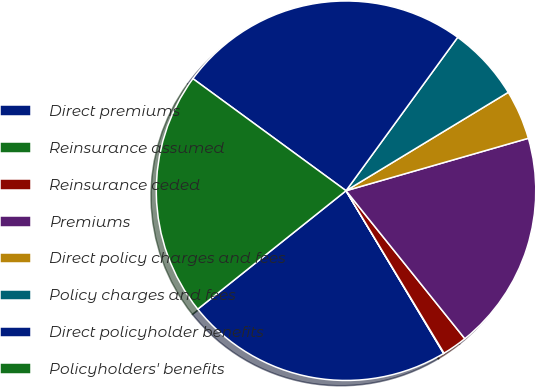Convert chart. <chart><loc_0><loc_0><loc_500><loc_500><pie_chart><fcel>Direct premiums<fcel>Reinsurance assumed<fcel>Reinsurance ceded<fcel>Premiums<fcel>Direct policy charges and fees<fcel>Policy charges and fees<fcel>Direct policyholder benefits<fcel>Policyholders' benefits<nl><fcel>22.87%<fcel>0.04%<fcel>2.13%<fcel>18.69%<fcel>4.22%<fcel>6.31%<fcel>24.96%<fcel>20.78%<nl></chart> 